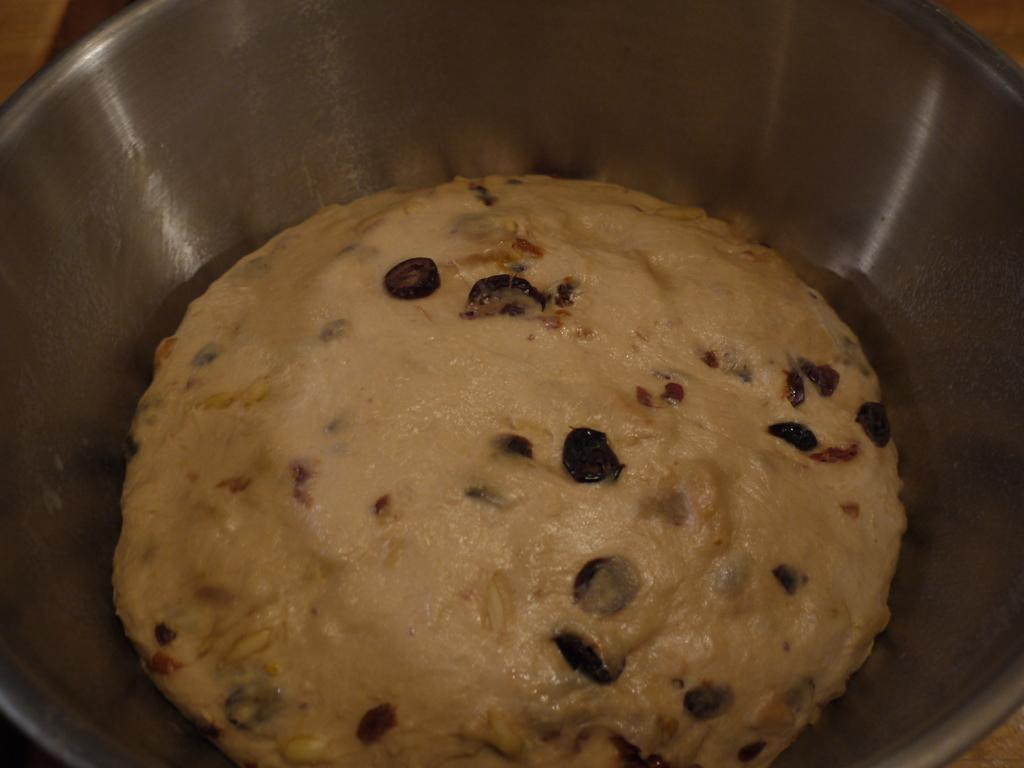What is the main subject of the image? The main subject of the image is a pudding. How is the pudding presented in the image? The pudding is placed in a bowl. What type of war is depicted in the image? There is no war depicted in the image; it features a pudding placed in a bowl. What scientific discovery can be observed in the image? There is no scientific discovery present in the image; it features a pudding placed in a bowl. 